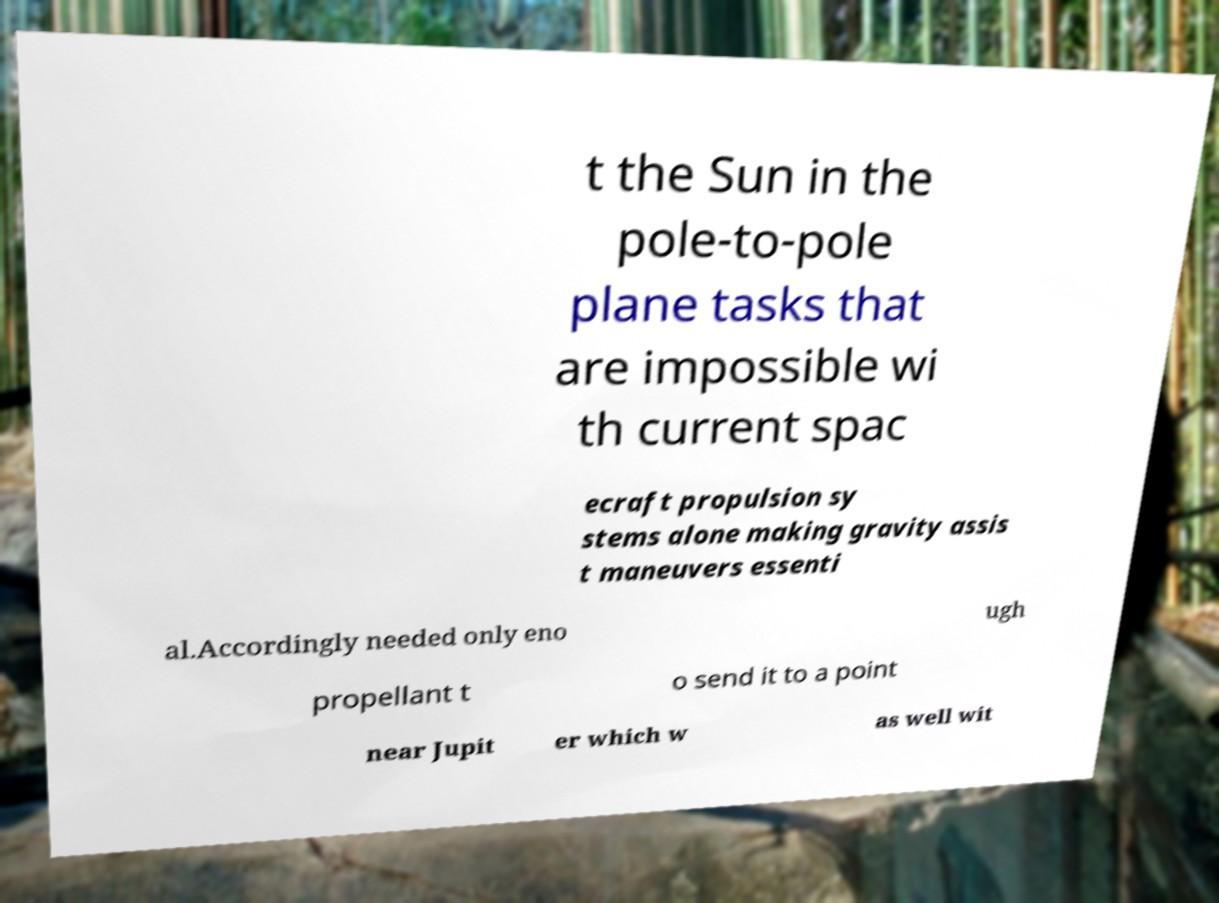Can you accurately transcribe the text from the provided image for me? t the Sun in the pole-to-pole plane tasks that are impossible wi th current spac ecraft propulsion sy stems alone making gravity assis t maneuvers essenti al.Accordingly needed only eno ugh propellant t o send it to a point near Jupit er which w as well wit 